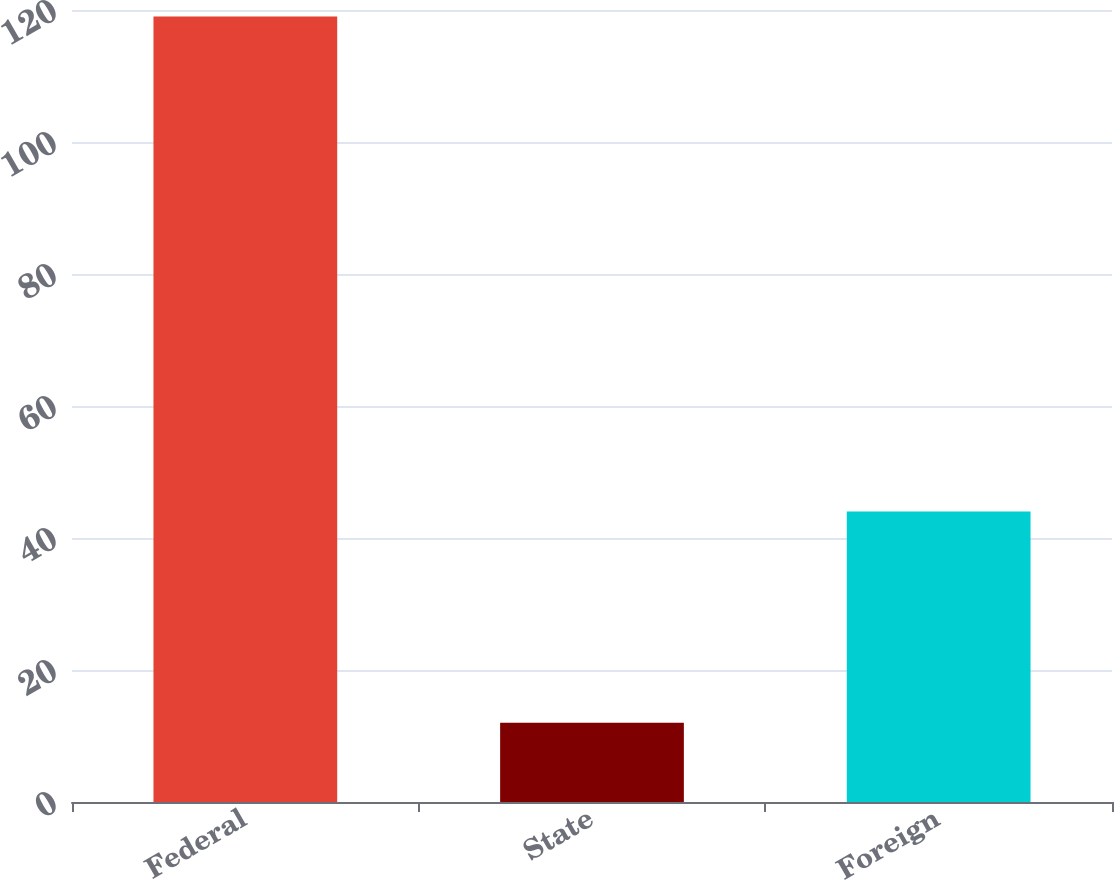Convert chart. <chart><loc_0><loc_0><loc_500><loc_500><bar_chart><fcel>Federal<fcel>State<fcel>Foreign<nl><fcel>119<fcel>12<fcel>44<nl></chart> 